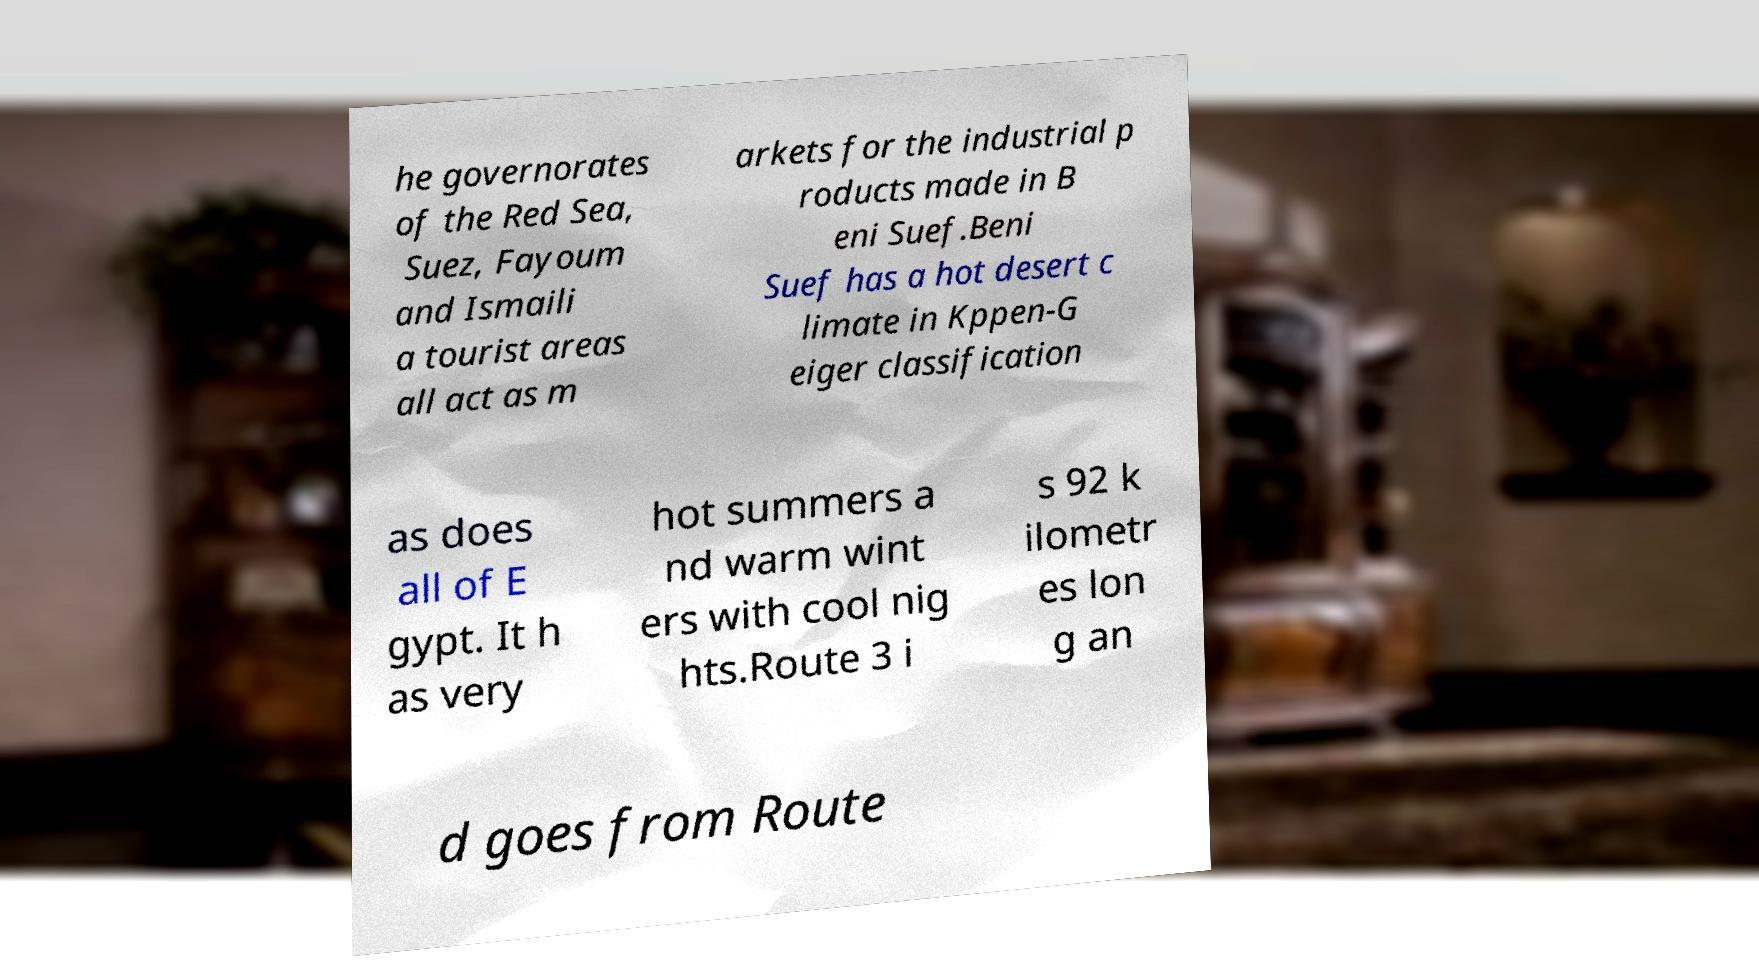Can you accurately transcribe the text from the provided image for me? he governorates of the Red Sea, Suez, Fayoum and Ismaili a tourist areas all act as m arkets for the industrial p roducts made in B eni Suef.Beni Suef has a hot desert c limate in Kppen-G eiger classification as does all of E gypt. It h as very hot summers a nd warm wint ers with cool nig hts.Route 3 i s 92 k ilometr es lon g an d goes from Route 